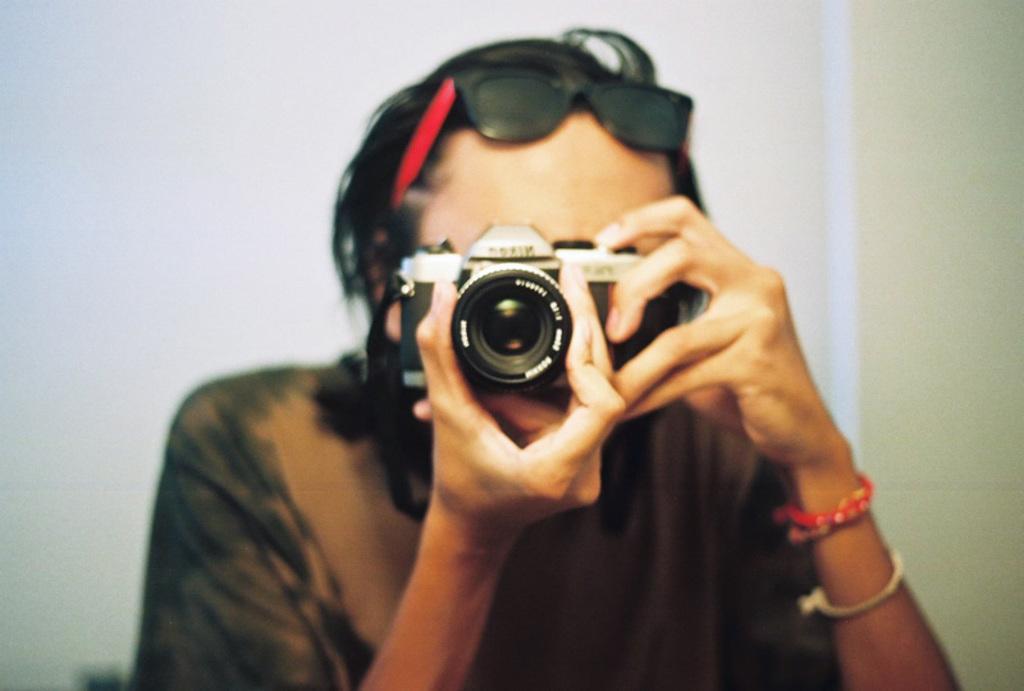Can you describe this image briefly? In this image there is a person holding the camera. In the background of the image there is a wall. 